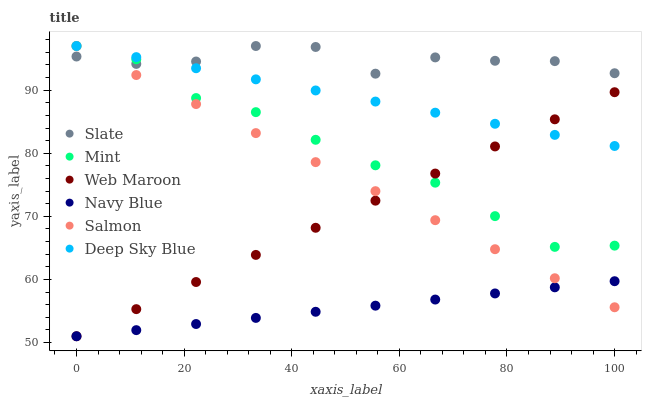Does Navy Blue have the minimum area under the curve?
Answer yes or no. Yes. Does Slate have the maximum area under the curve?
Answer yes or no. Yes. Does Web Maroon have the minimum area under the curve?
Answer yes or no. No. Does Web Maroon have the maximum area under the curve?
Answer yes or no. No. Is Navy Blue the smoothest?
Answer yes or no. Yes. Is Slate the roughest?
Answer yes or no. Yes. Is Web Maroon the smoothest?
Answer yes or no. No. Is Web Maroon the roughest?
Answer yes or no. No. Does Web Maroon have the lowest value?
Answer yes or no. Yes. Does Slate have the lowest value?
Answer yes or no. No. Does Mint have the highest value?
Answer yes or no. Yes. Does Web Maroon have the highest value?
Answer yes or no. No. Is Navy Blue less than Slate?
Answer yes or no. Yes. Is Slate greater than Web Maroon?
Answer yes or no. Yes. Does Mint intersect Web Maroon?
Answer yes or no. Yes. Is Mint less than Web Maroon?
Answer yes or no. No. Is Mint greater than Web Maroon?
Answer yes or no. No. Does Navy Blue intersect Slate?
Answer yes or no. No. 